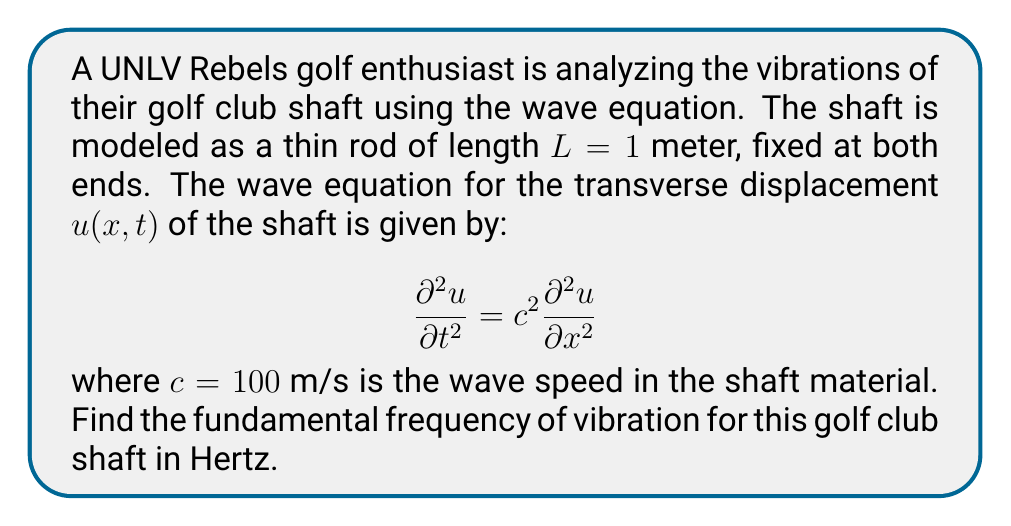Solve this math problem. To solve this problem, we'll follow these steps:

1) For a string fixed at both ends, the general solution to the wave equation is:

   $$u(x,t) = \sum_{n=1}^{\infty} A_n \sin(\frac{n\pi x}{L}) \cos(\frac{n\pi c t}{L})$$

2) The fundamental frequency corresponds to $n=1$. The angular frequency $\omega$ for this mode is:

   $$\omega = \frac{\pi c}{L}$$

3) Substituting the given values:

   $$\omega = \frac{\pi \cdot 100 \text{ m/s}}{1 \text{ m}} = 100\pi \text{ rad/s}$$

4) To convert from angular frequency to frequency in Hertz, we use the relation:

   $$f = \frac{\omega}{2\pi}$$

5) Therefore, the fundamental frequency is:

   $$f = \frac{100\pi \text{ rad/s}}{2\pi} = 50 \text{ Hz}$$

Thus, the fundamental frequency of vibration for the golf club shaft is 50 Hz.
Answer: 50 Hz 